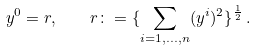<formula> <loc_0><loc_0><loc_500><loc_500>y ^ { 0 } = r , \quad r \colon = \{ \sum _ { i = 1 , \dots , n } ( y ^ { i } ) ^ { 2 } \} ^ { \frac { 1 } { 2 } } \, .</formula> 